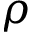<formula> <loc_0><loc_0><loc_500><loc_500>\rho</formula> 